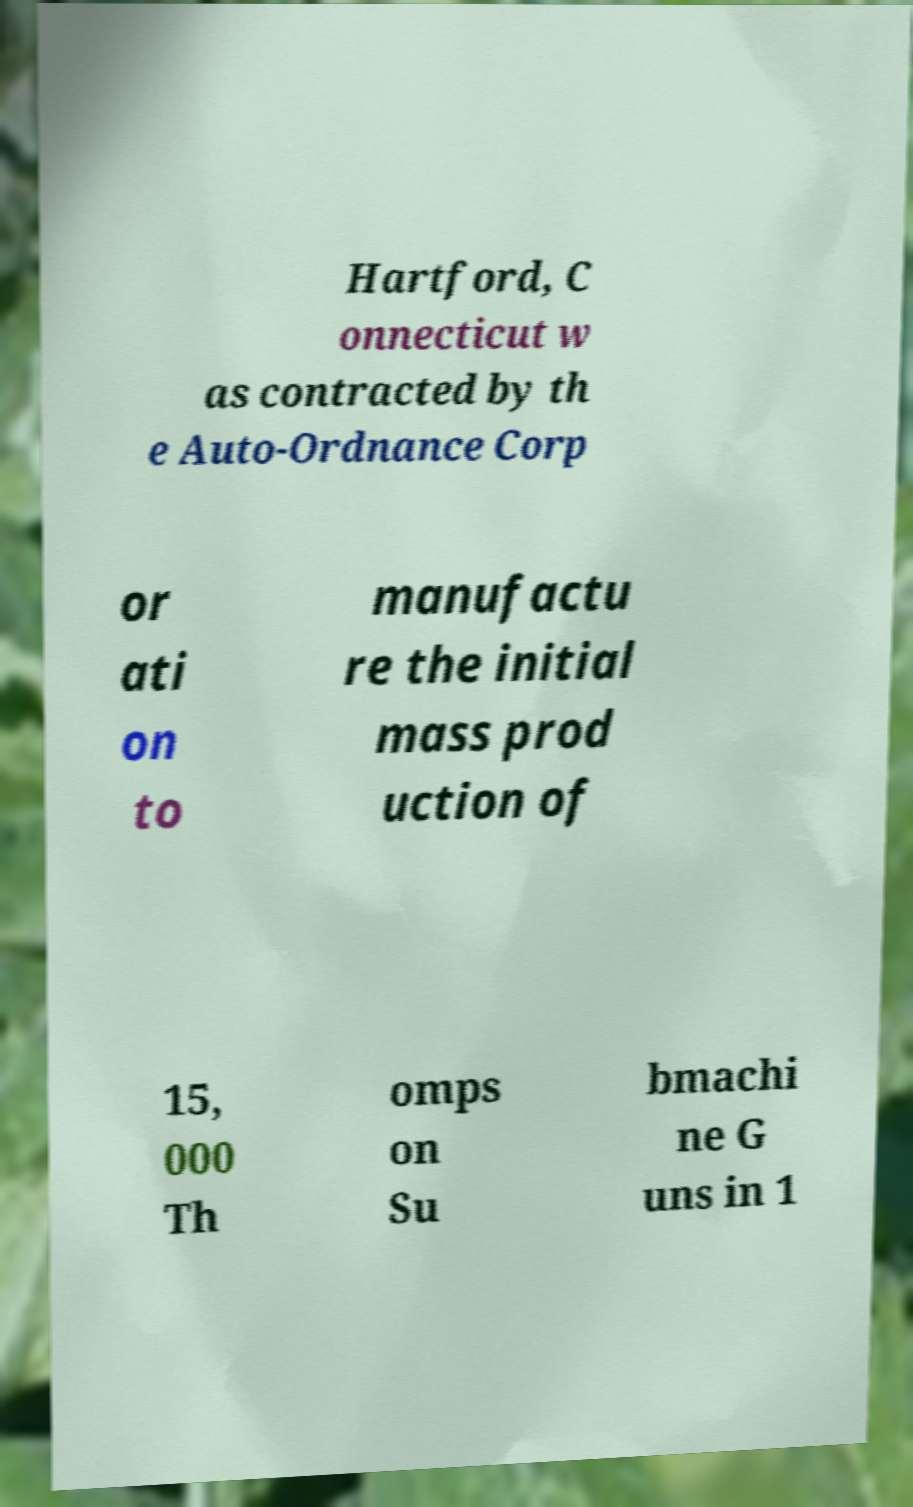I need the written content from this picture converted into text. Can you do that? Hartford, C onnecticut w as contracted by th e Auto-Ordnance Corp or ati on to manufactu re the initial mass prod uction of 15, 000 Th omps on Su bmachi ne G uns in 1 